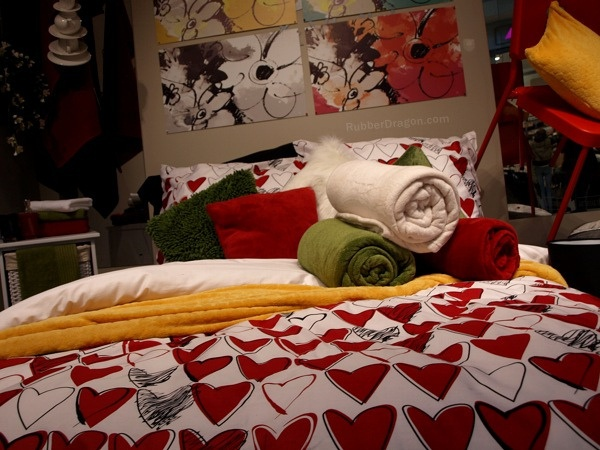Describe the objects in this image and their specific colors. I can see a bed in black, maroon, darkgray, and gray tones in this image. 